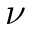<formula> <loc_0><loc_0><loc_500><loc_500>\nu</formula> 